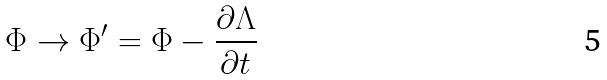Convert formula to latex. <formula><loc_0><loc_0><loc_500><loc_500>\Phi \rightarrow \Phi ^ { \prime } = \Phi - \frac { \partial \Lambda } { \partial t }</formula> 